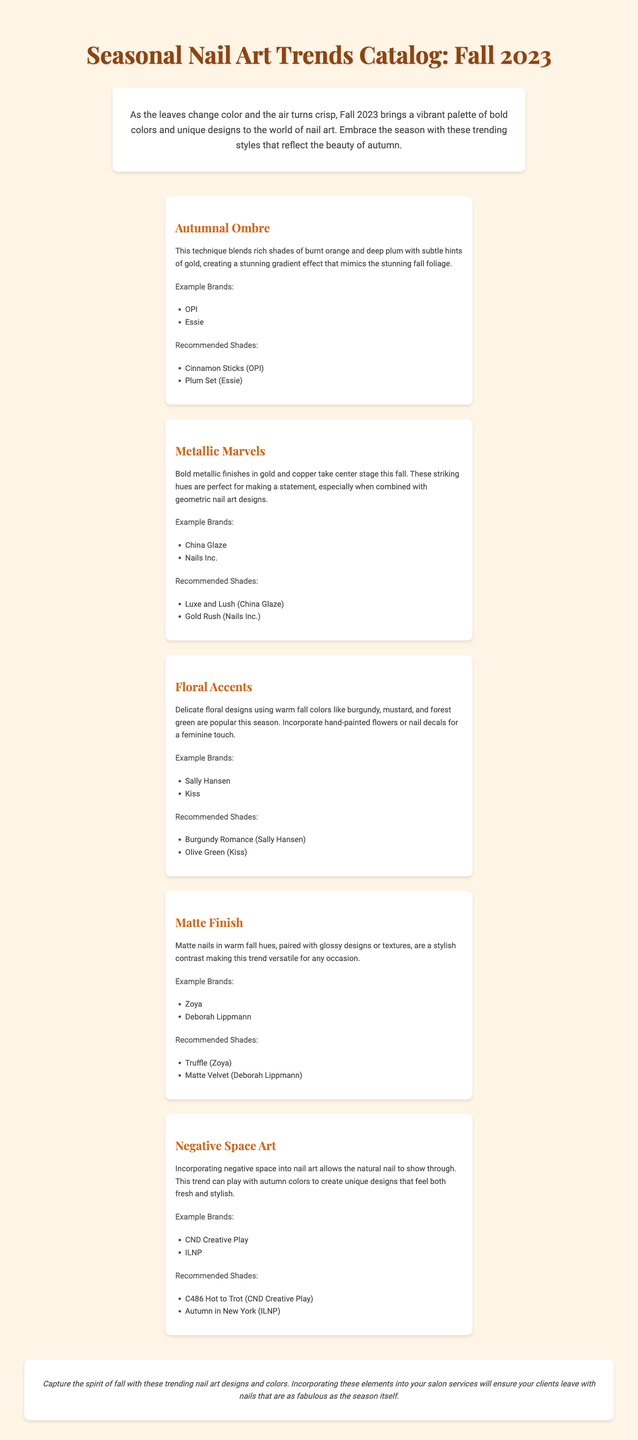What is the title of the catalog? The title of the catalog is provided in the document's header section.
Answer: Seasonal Nail Art Trends Catalog: Fall 2023 What is a recommended shade for the Autumnal Ombre trend? This information is specified under the Autumnal Ombre trend section, which lists recommended shades.
Answer: Cinnamon Sticks (OPI) Which brands are associated with the Metallic Marvels trend? Example brands are listed under the Metallic Marvels section as part of the trend description.
Answer: China Glaze, Nails Inc What color theme is prominent in the Floral Accents trend? The description of the Floral Accents trend mentions specific colors used in the designs.
Answer: Burgundy, mustard, forest green How does the Matte Finish trend enhance design versatility? The description explains how matte nails can be paired, indicating design combinations.
Answer: Glossy designs or textures Which trend involves utilizing the natural nail's visibility? This trend is discussed in terms of its unique approach and design style.
Answer: Negative Space Art How many trends are featured in this catalog? The document lists each trend separately, indicating the total number of trends presented.
Answer: Five Who are the example brands mentioned for the Negative Space Art trend? The list of example brands for this trend is clearly stated in its section, providing the relevant names.
Answer: CND Creative Play, ILNP What seasonal elements are reflected in the catalog's introduction? The introduction summarizes the overall theme and colors relevant to the season presented.
Answer: Vibrant palette of bold colors and unique designs 